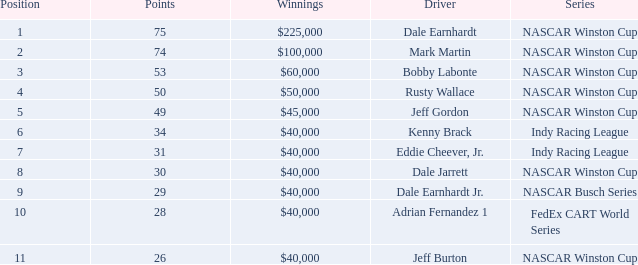In what series did Bobby Labonte drive? NASCAR Winston Cup. 